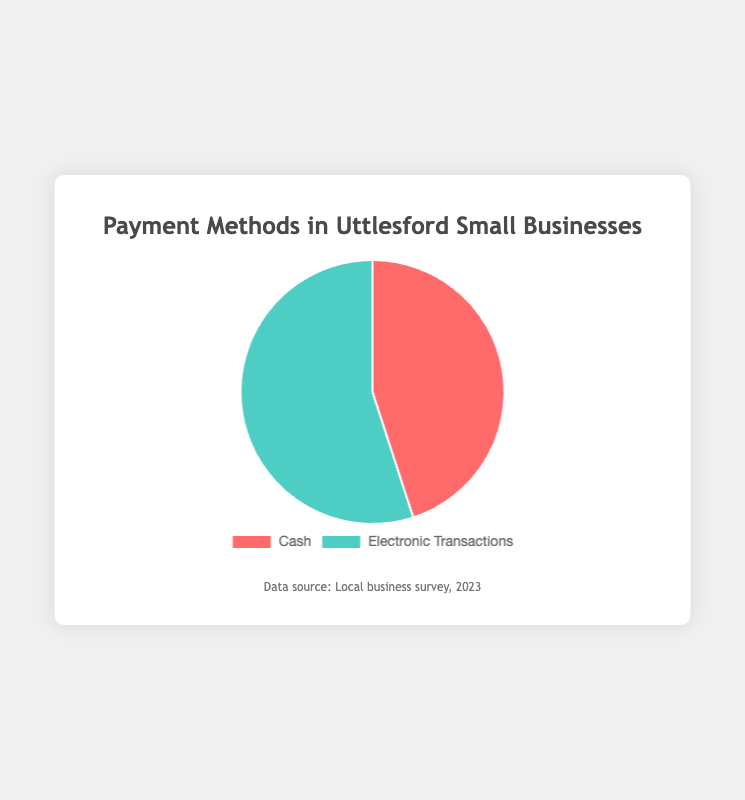What's the percentage of cash transactions? The pie chart shows two segments: "Cash" and "Electronic Transactions." The segment labeled "Cash" has a percentage of 45%.
Answer: 45% What's the percentage of electronic transactions? According to the pie chart, the segment labeled "Electronic Transactions" has a percentage of 55%.
Answer: 55% Which payment type is more popular? By comparing the percentages, "Electronic Transactions" at 55% are more popular than "Cash" at 45%.
Answer: Electronic Transactions By how much do electronic transactions exceed cash transactions? Electronic transactions account for 55% and cash transactions 45%. Subtracting these two percentages: 55% - 45% = 10%.
Answer: 10% What is the difference in popularity between the two payment methods? The difference can be calculated by subtracting the percentage of cash transactions from electronic transactions: 55% - 45% = 10%.
Answer: 10% Are electronic transactions used more than half of the time? The percentage for electronic transactions is 55%, which is greater than 50%.
Answer: Yes If a business conducted 100 transactions, how many of them would be electronic? With electronic transactions making up 55%, out of 100 transactions: 100 * 0.55 = 55 transactions would be electronic.
Answer: 55 What color represents cash transactions? According to the pie chart, the segment for "Cash" is colored red.
Answer: Red What color represents electronic transactions? The pie chart indicates that "Electronic Transactions" are represented in green.
Answer: Green If the percentage of cash transactions increases by 5%, what will be the new percentage for electronic transactions? Currently, cash transactions are 45%. If they increase by 5%, they become 50%. Since the total must be 100%, electronic transactions will then be 100% - 50% = 50%.
Answer: 50% 